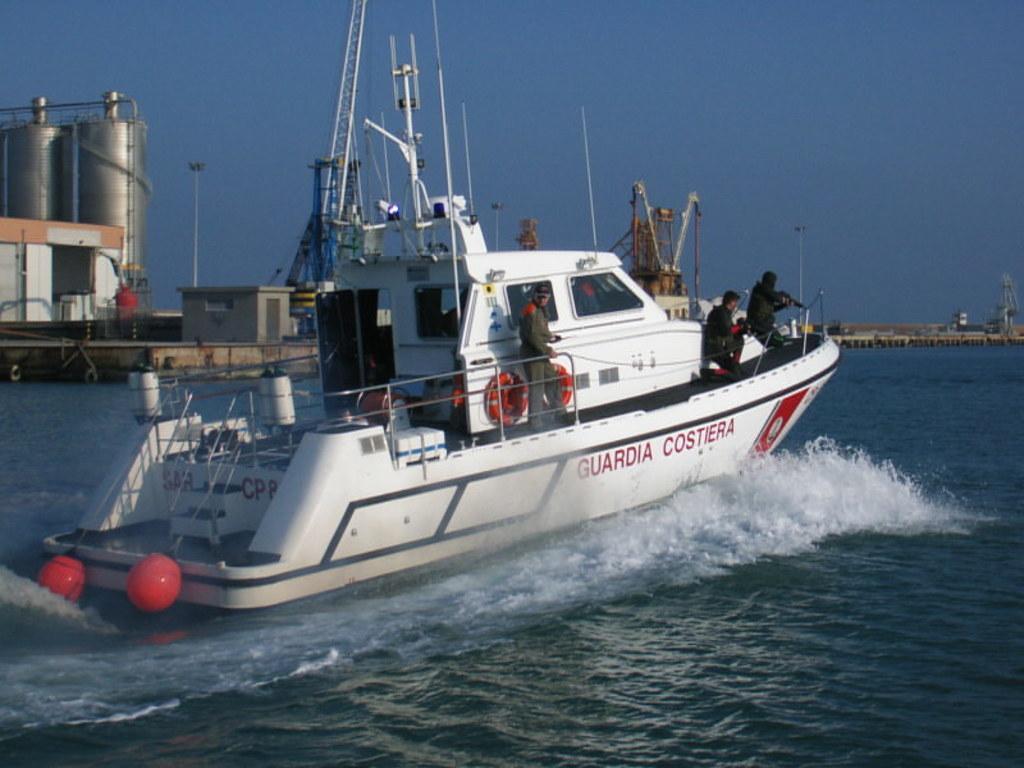Describe this image in one or two sentences. In this image we can see few persons are on the boat on the water and we can see swimming rings, railings, poles and objects. In the background we can see huge cylindrical tanks, metal objects, buildings, poles and the sky. 